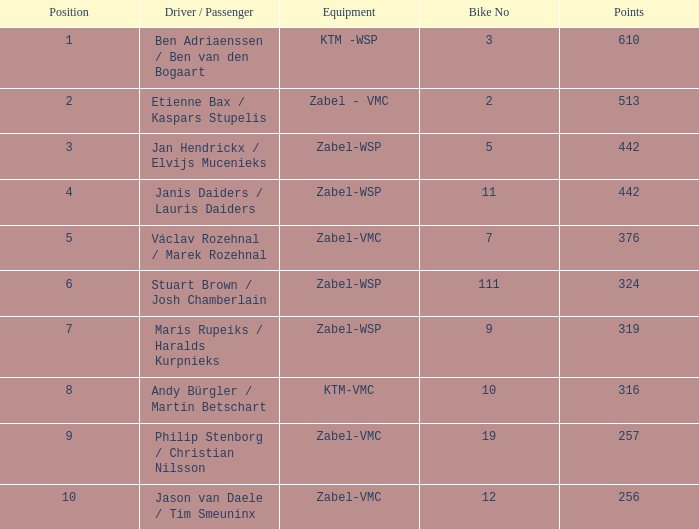Parse the table in full. {'header': ['Position', 'Driver / Passenger', 'Equipment', 'Bike No', 'Points'], 'rows': [['1', 'Ben Adriaenssen / Ben van den Bogaart', 'KTM -WSP', '3', '610'], ['2', 'Etienne Bax / Kaspars Stupelis', 'Zabel - VMC', '2', '513'], ['3', 'Jan Hendrickx / Elvijs Mucenieks', 'Zabel-WSP', '5', '442'], ['4', 'Janis Daiders / Lauris Daiders', 'Zabel-WSP', '11', '442'], ['5', 'Václav Rozehnal / Marek Rozehnal', 'Zabel-VMC', '7', '376'], ['6', 'Stuart Brown / Josh Chamberlain', 'Zabel-WSP', '111', '324'], ['7', 'Maris Rupeiks / Haralds Kurpnieks', 'Zabel-WSP', '9', '319'], ['8', 'Andy Bürgler / Martin Betschart', 'KTM-VMC', '10', '316'], ['9', 'Philip Stenborg / Christian Nilsson', 'Zabel-VMC', '19', '257'], ['10', 'Jason van Daele / Tim Smeuninx', 'Zabel-VMC', '12', '256']]} What is the Equipment that has a Point bigger than 256, and a Position of 3? Zabel-WSP. 